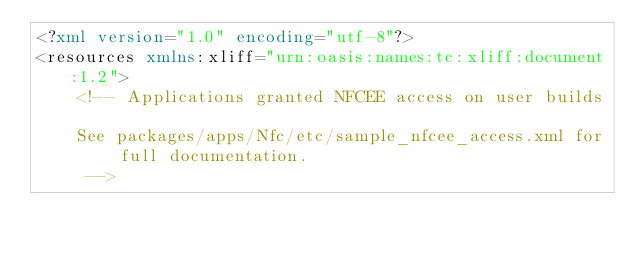<code> <loc_0><loc_0><loc_500><loc_500><_XML_><?xml version="1.0" encoding="utf-8"?>
<resources xmlns:xliff="urn:oasis:names:tc:xliff:document:1.2">
    <!-- Applications granted NFCEE access on user builds

    See packages/apps/Nfc/etc/sample_nfcee_access.xml for full documentation.
     -->
</code> 